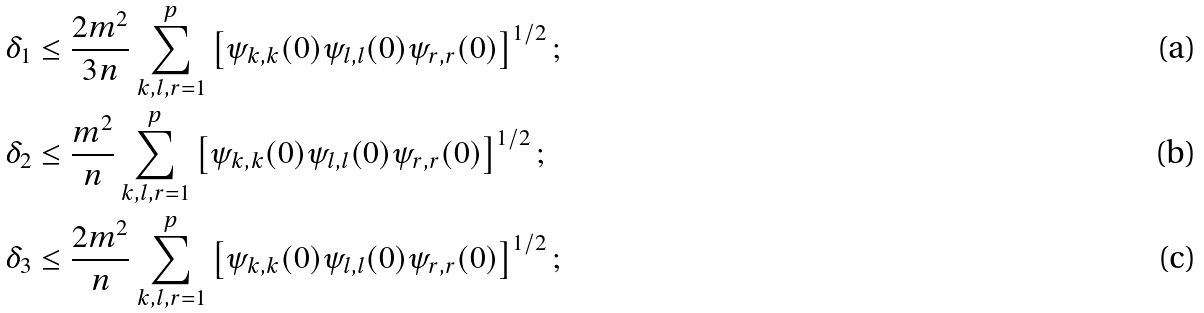<formula> <loc_0><loc_0><loc_500><loc_500>& \delta _ { 1 } \leq \frac { 2 m ^ { 2 } } { 3 n } \sum _ { k , l , r = 1 } ^ { p } \left [ \psi _ { k , k } ( 0 ) \psi _ { l , l } ( 0 ) \psi _ { r , r } ( 0 ) \right ] ^ { 1 / 2 } ; & \\ & \delta _ { 2 } \leq \frac { m ^ { 2 } } { n } \sum _ { k , l , r = 1 } ^ { p } \left [ \psi _ { k , k } ( 0 ) \psi _ { l , l } ( 0 ) \psi _ { r , r } ( 0 ) \right ] ^ { 1 / 2 } ; & \\ & \delta _ { 3 } \leq \frac { 2 m ^ { 2 } } { n } \sum _ { k , l , r = 1 } ^ { p } \left [ \psi _ { k , k } ( 0 ) \psi _ { l , l } ( 0 ) \psi _ { r , r } ( 0 ) \right ] ^ { 1 / 2 } ; &</formula> 